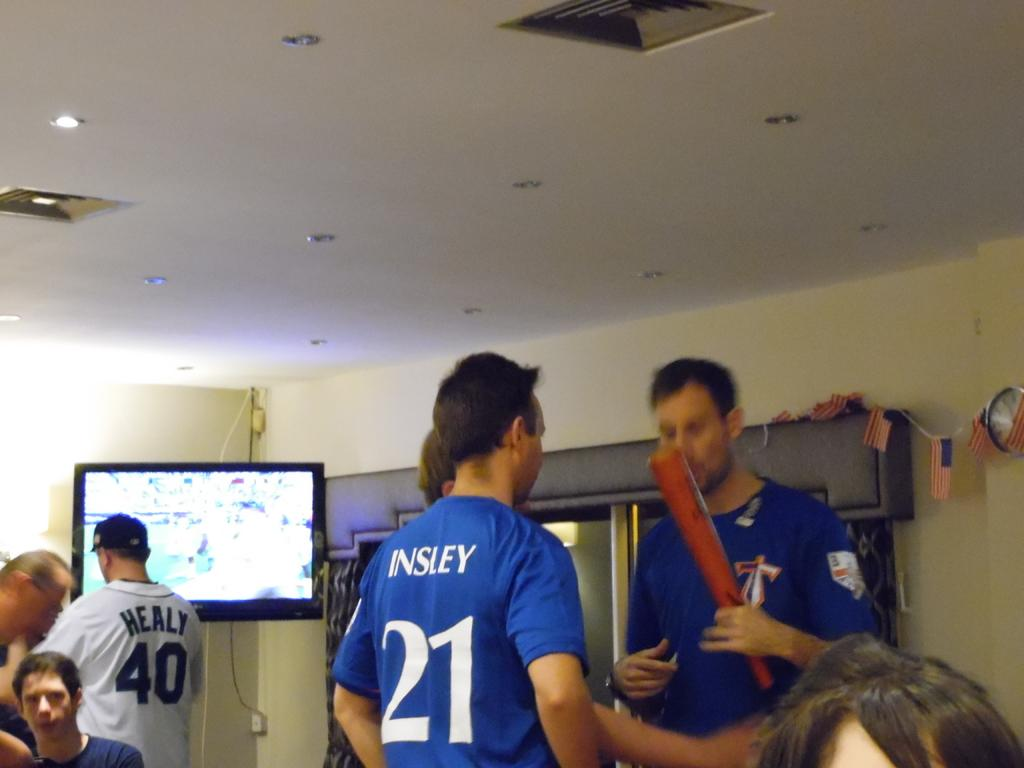Provide a one-sentence caption for the provided image. A man in a blue jersey with the number 21 is talking with a group of people. 